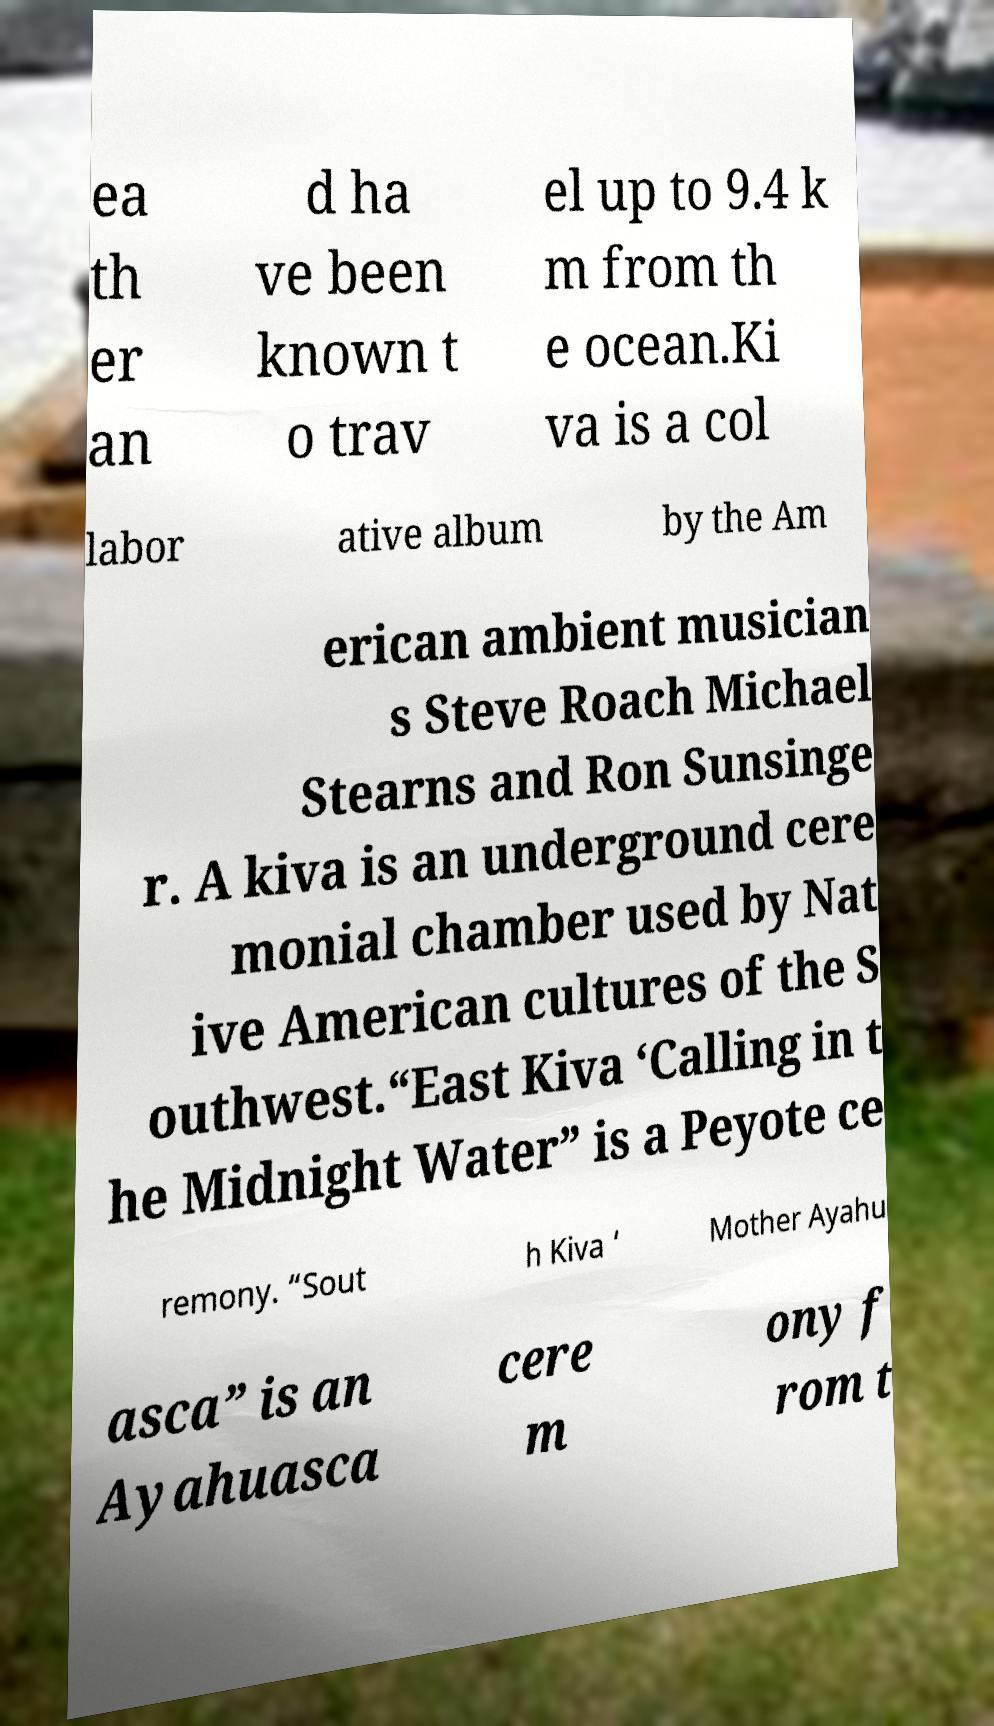There's text embedded in this image that I need extracted. Can you transcribe it verbatim? ea th er an d ha ve been known t o trav el up to 9.4 k m from th e ocean.Ki va is a col labor ative album by the Am erican ambient musician s Steve Roach Michael Stearns and Ron Sunsinge r. A kiva is an underground cere monial chamber used by Nat ive American cultures of the S outhwest.“East Kiva ‘Calling in t he Midnight Water” is a Peyote ce remony. “Sout h Kiva ‘ Mother Ayahu asca” is an Ayahuasca cere m ony f rom t 